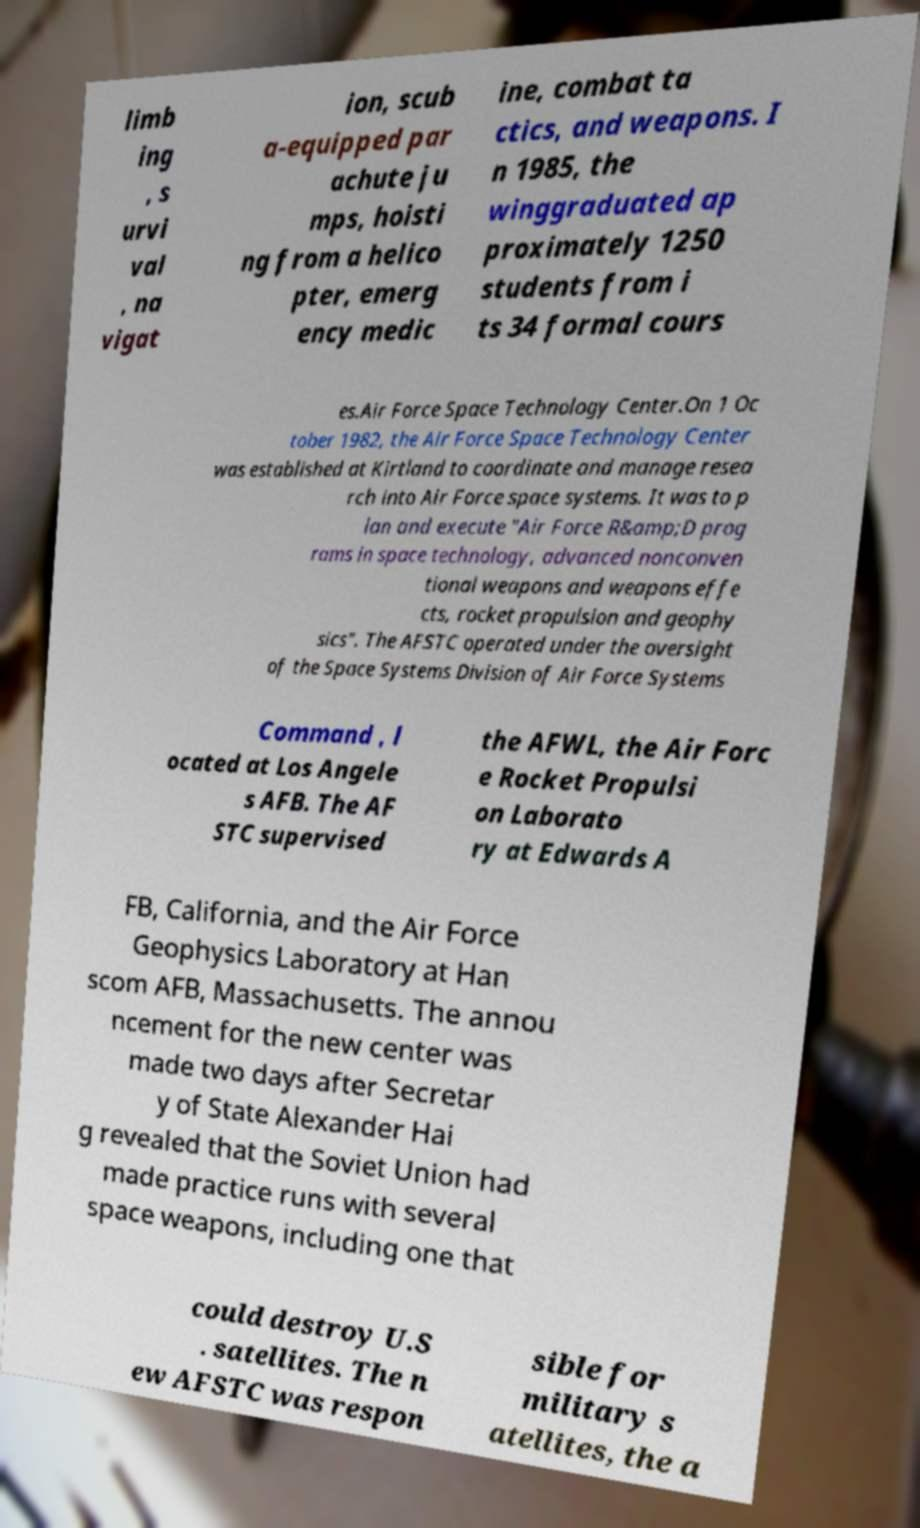Can you accurately transcribe the text from the provided image for me? limb ing , s urvi val , na vigat ion, scub a-equipped par achute ju mps, hoisti ng from a helico pter, emerg ency medic ine, combat ta ctics, and weapons. I n 1985, the winggraduated ap proximately 1250 students from i ts 34 formal cours es.Air Force Space Technology Center.On 1 Oc tober 1982, the Air Force Space Technology Center was established at Kirtland to coordinate and manage resea rch into Air Force space systems. It was to p lan and execute "Air Force R&amp;D prog rams in space technology, advanced nonconven tional weapons and weapons effe cts, rocket propulsion and geophy sics". The AFSTC operated under the oversight of the Space Systems Division of Air Force Systems Command , l ocated at Los Angele s AFB. The AF STC supervised the AFWL, the Air Forc e Rocket Propulsi on Laborato ry at Edwards A FB, California, and the Air Force Geophysics Laboratory at Han scom AFB, Massachusetts. The annou ncement for the new center was made two days after Secretar y of State Alexander Hai g revealed that the Soviet Union had made practice runs with several space weapons, including one that could destroy U.S . satellites. The n ew AFSTC was respon sible for military s atellites, the a 